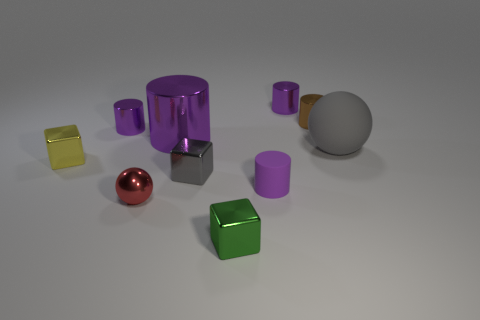The large object that is the same color as the small matte object is what shape?
Your answer should be compact. Cylinder. There is a green object that is made of the same material as the small yellow block; what is its size?
Provide a short and direct response. Small. There is a cylinder in front of the yellow block; is it the same color as the large metal cylinder?
Your response must be concise. Yes. There is a gray thing left of the tiny purple thing in front of the gray shiny cube; what size is it?
Offer a very short reply. Small. Is the number of red things greater than the number of small matte balls?
Offer a terse response. Yes. Are there more brown objects behind the big rubber ball than big metal cylinders left of the shiny ball?
Offer a very short reply. Yes. There is a thing that is both in front of the yellow metallic cube and on the left side of the small gray cube; what is its size?
Provide a succinct answer. Small. How many green metal blocks have the same size as the brown metal object?
Provide a short and direct response. 1. There is a gray thing to the right of the green metal cube; does it have the same shape as the small red shiny thing?
Your answer should be compact. Yes. Is the number of yellow blocks in front of the yellow block less than the number of small yellow metallic objects?
Offer a very short reply. Yes. 